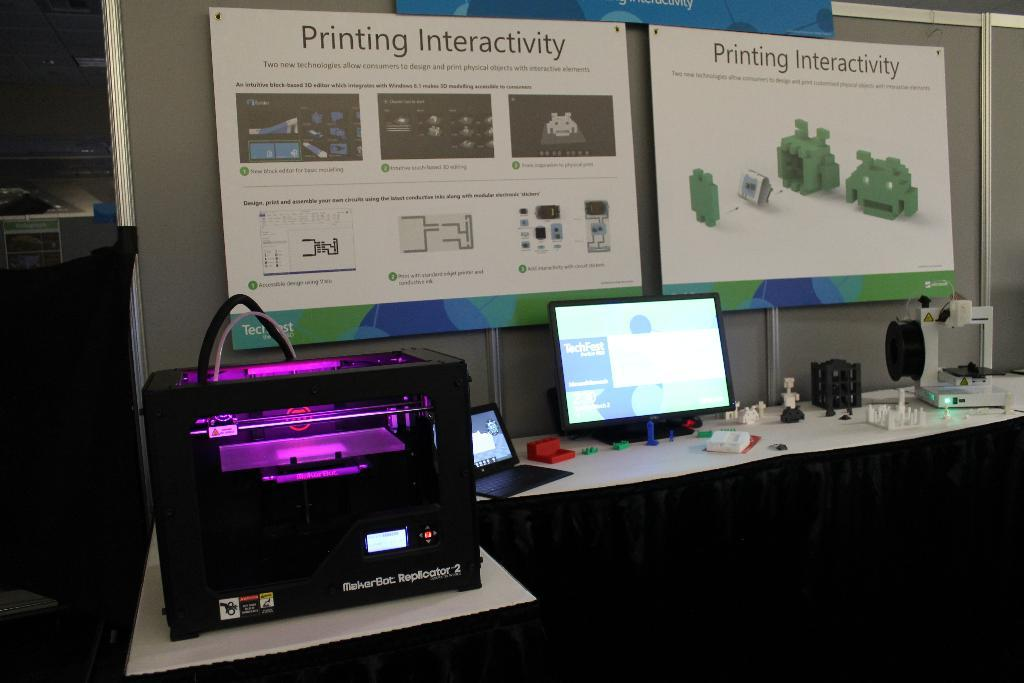<image>
Create a compact narrative representing the image presented. Standing at a desk set up with a printing interactivity event,with a large nice printer and computer. 